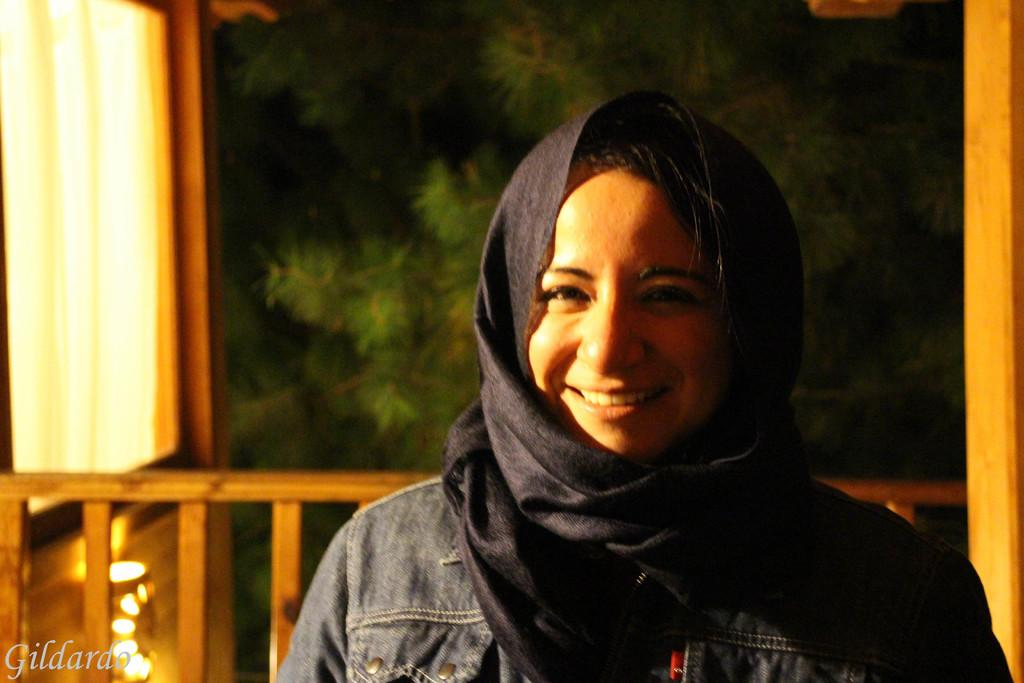Who is in the image? There is a woman in the image. What is the woman doing in the image? The woman is smiling in the image. What can be seen in the background or surrounding the woman? There are lights visible in the image. What material is present in the image? There is cloth present in the image. How does the wind affect the woman's hair in the image? There is no wind present in the image, so it cannot affect the woman's hair. 